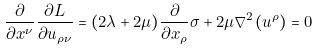<formula> <loc_0><loc_0><loc_500><loc_500>\frac { \partial } { \partial x ^ { \nu } } \frac { \partial L } { \partial u _ { \rho \nu } } = ( 2 \lambda + 2 \mu ) \frac { \partial } { \partial x _ { \rho } } \sigma + 2 \mu \nabla ^ { 2 } ( u ^ { \rho } ) = 0</formula> 